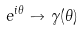<formula> <loc_0><loc_0><loc_500><loc_500>e ^ { i \theta } \to \gamma ( \theta )</formula> 